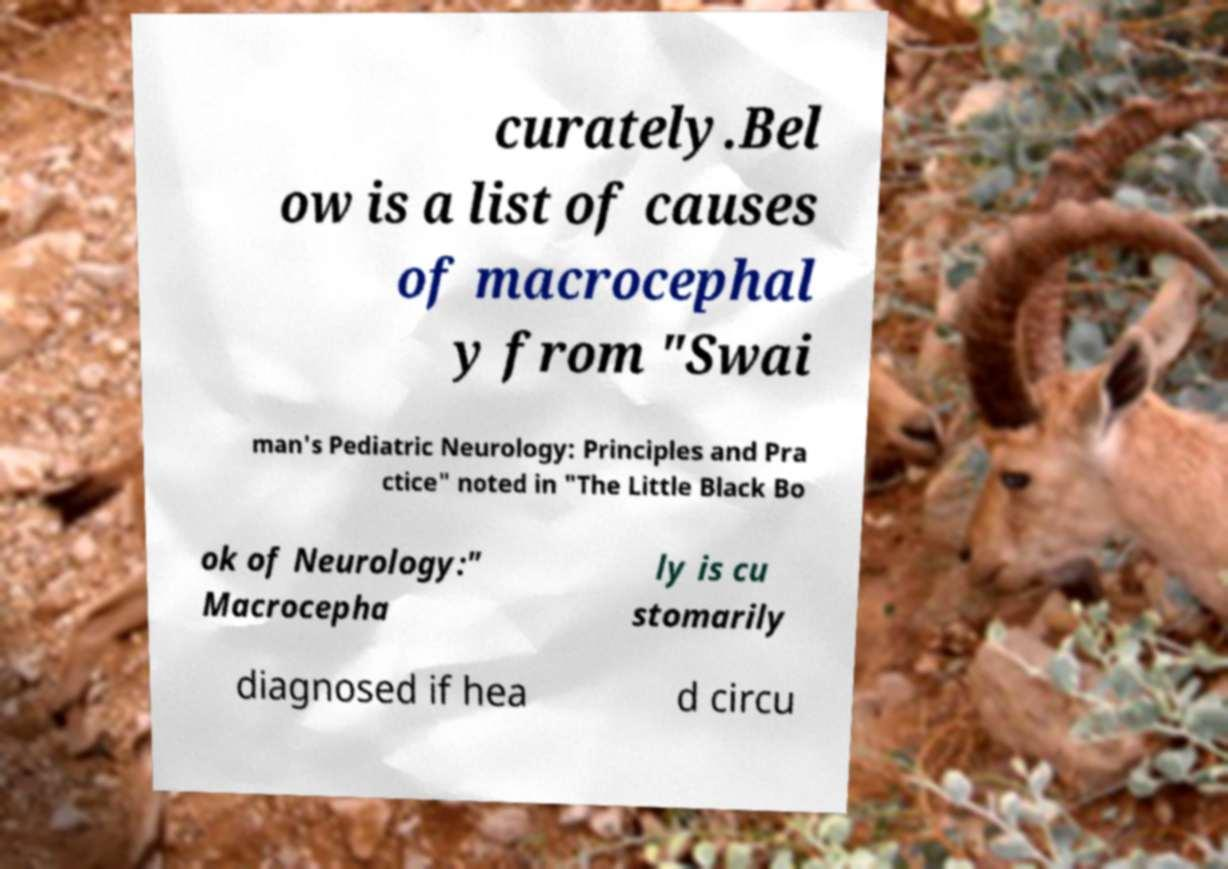Could you extract and type out the text from this image? curately.Bel ow is a list of causes of macrocephal y from "Swai man's Pediatric Neurology: Principles and Pra ctice" noted in "The Little Black Bo ok of Neurology:" Macrocepha ly is cu stomarily diagnosed if hea d circu 